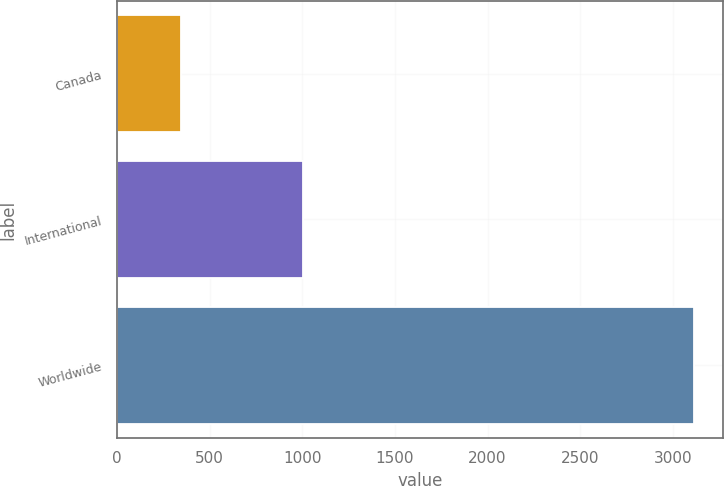Convert chart to OTSL. <chart><loc_0><loc_0><loc_500><loc_500><bar_chart><fcel>Canada<fcel>International<fcel>Worldwide<nl><fcel>344<fcel>1005<fcel>3116<nl></chart> 